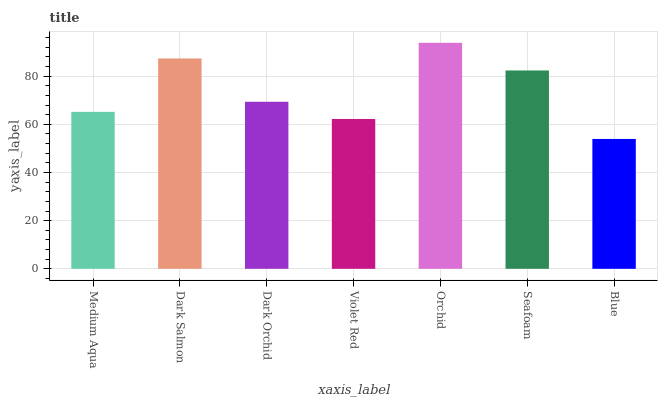Is Blue the minimum?
Answer yes or no. Yes. Is Orchid the maximum?
Answer yes or no. Yes. Is Dark Salmon the minimum?
Answer yes or no. No. Is Dark Salmon the maximum?
Answer yes or no. No. Is Dark Salmon greater than Medium Aqua?
Answer yes or no. Yes. Is Medium Aqua less than Dark Salmon?
Answer yes or no. Yes. Is Medium Aqua greater than Dark Salmon?
Answer yes or no. No. Is Dark Salmon less than Medium Aqua?
Answer yes or no. No. Is Dark Orchid the high median?
Answer yes or no. Yes. Is Dark Orchid the low median?
Answer yes or no. Yes. Is Blue the high median?
Answer yes or no. No. Is Medium Aqua the low median?
Answer yes or no. No. 